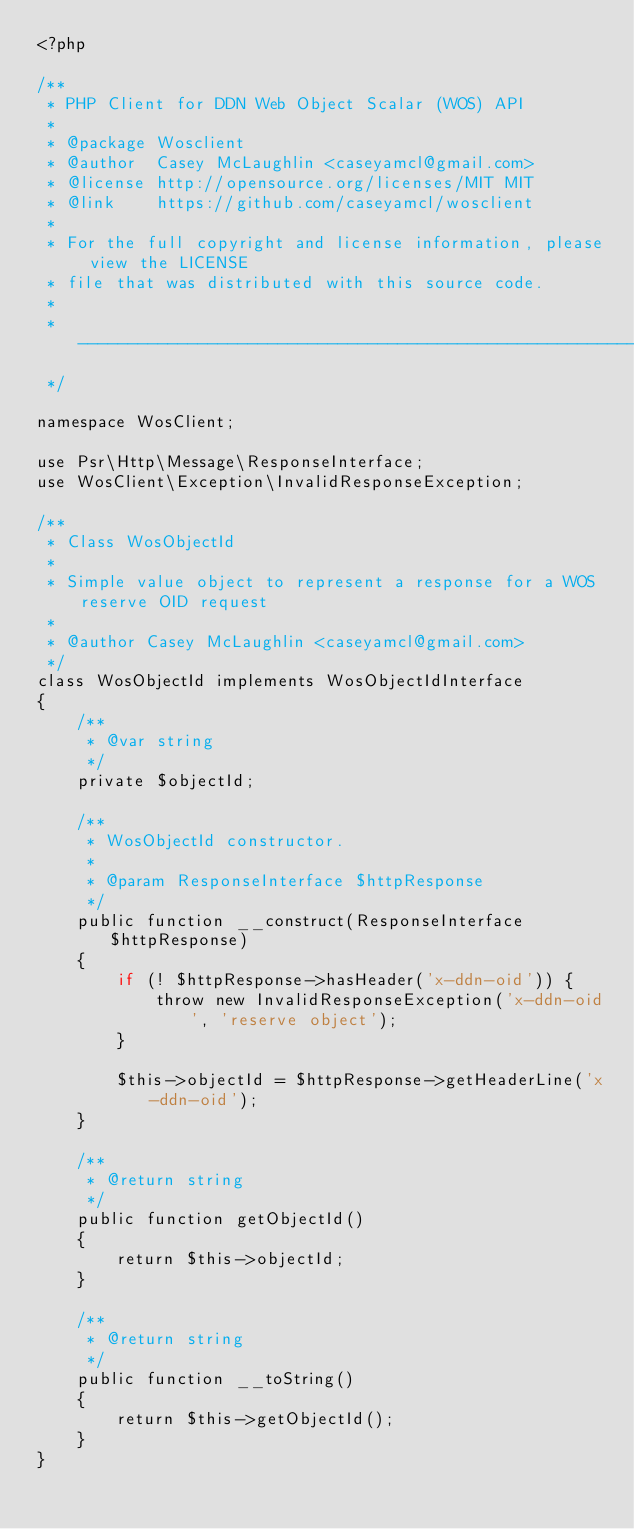Convert code to text. <code><loc_0><loc_0><loc_500><loc_500><_PHP_><?php

/**
 * PHP Client for DDN Web Object Scalar (WOS) API
 *
 * @package Wosclient
 * @author  Casey McLaughlin <caseyamcl@gmail.com>
 * @license http://opensource.org/licenses/MIT MIT
 * @link    https://github.com/caseyamcl/wosclient
 *
 * For the full copyright and license information, please view the LICENSE
 * file that was distributed with this source code.
 *
 * ------------------------------------------------------------------
 */

namespace WosClient;

use Psr\Http\Message\ResponseInterface;
use WosClient\Exception\InvalidResponseException;

/**
 * Class WosObjectId
 *
 * Simple value object to represent a response for a WOS reserve OID request
 *
 * @author Casey McLaughlin <caseyamcl@gmail.com>
 */
class WosObjectId implements WosObjectIdInterface
{
    /**
     * @var string
     */
    private $objectId;

    /**
     * WosObjectId constructor.
     *
     * @param ResponseInterface $httpResponse
     */
    public function __construct(ResponseInterface $httpResponse)
    {
        if (! $httpResponse->hasHeader('x-ddn-oid')) {
            throw new InvalidResponseException('x-ddn-oid', 'reserve object');
        }

        $this->objectId = $httpResponse->getHeaderLine('x-ddn-oid');
    }

    /**
     * @return string
     */
    public function getObjectId()
    {
        return $this->objectId;
    }

    /**
     * @return string
     */
    public function __toString()
    {
        return $this->getObjectId();
    }
}
</code> 